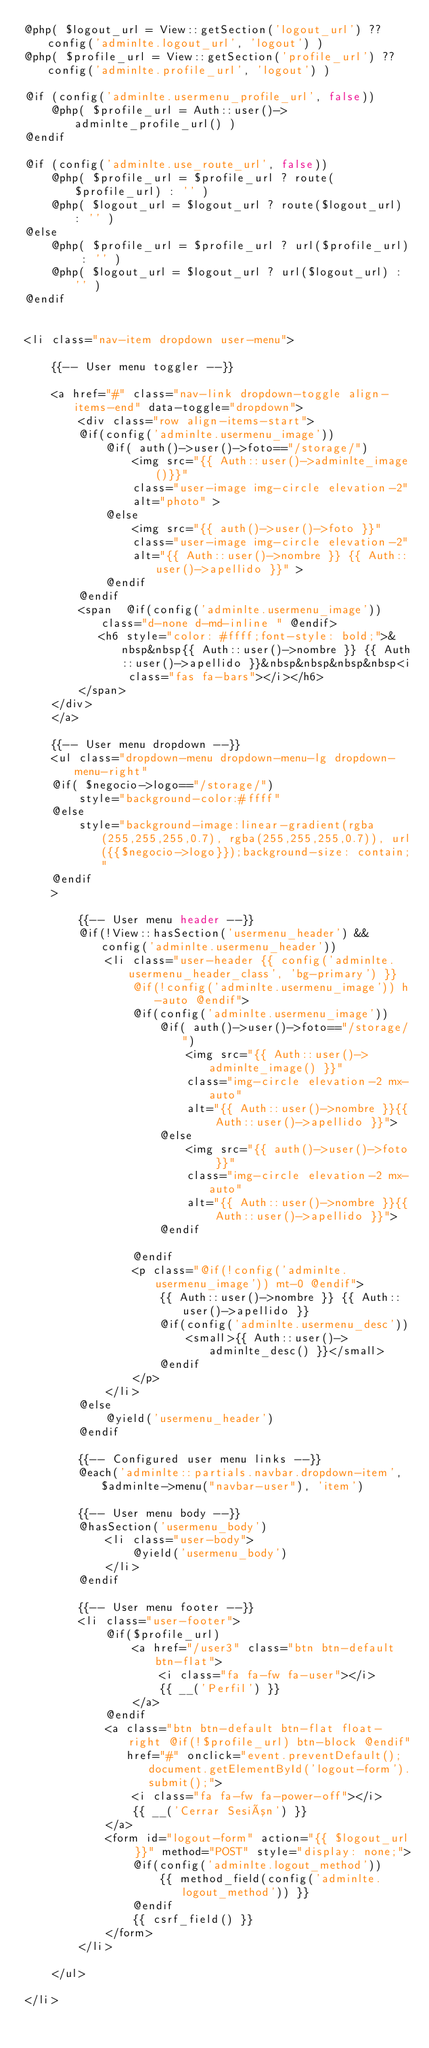<code> <loc_0><loc_0><loc_500><loc_500><_PHP_>@php( $logout_url = View::getSection('logout_url') ?? config('adminlte.logout_url', 'logout') )
@php( $profile_url = View::getSection('profile_url') ?? config('adminlte.profile_url', 'logout') )

@if (config('adminlte.usermenu_profile_url', false))
    @php( $profile_url = Auth::user()->adminlte_profile_url() )
@endif

@if (config('adminlte.use_route_url', false))
    @php( $profile_url = $profile_url ? route($profile_url) : '' )
    @php( $logout_url = $logout_url ? route($logout_url) : '' )
@else
    @php( $profile_url = $profile_url ? url($profile_url) : '' )
    @php( $logout_url = $logout_url ? url($logout_url) : '' )
@endif


<li class="nav-item dropdown user-menu">

    {{-- User menu toggler --}} 
    
    <a href="#" class="nav-link dropdown-toggle align-items-end" data-toggle="dropdown">
        <div class="row align-items-start">
        @if(config('adminlte.usermenu_image'))
            @if( auth()->user()->foto=="/storage/") 
                <img src="{{ Auth::user()->adminlte_image()}}"
                class="user-image img-circle elevation-2"
                alt="photo" >
            @else 
                <img src="{{ auth()->user()->foto }}"
                class="user-image img-circle elevation-2"
                alt="{{ Auth::user()->nombre }} {{ Auth::user()->apellido }}" >
            @endif
        @endif
        <span  @if(config('adminlte.usermenu_image')) class="d-none d-md-inline " @endif>
           <h6 style="color: #ffff;font-style: bold;">&nbsp&nbsp{{ Auth::user()->nombre }} {{ Auth::user()->apellido }}&nbsp&nbsp&nbsp&nbsp<i class="fas fa-bars"></i></h6>
        </span>
    </div>
    </a>
    
    {{-- User menu dropdown --}}
    <ul class="dropdown-menu dropdown-menu-lg dropdown-menu-right"
    @if( $negocio->logo=="/storage/")  
        style="background-color:#ffff" 
    @else
        style="background-image:linear-gradient(rgba(255,255,255,0.7), rgba(255,255,255,0.7)), url({{$negocio->logo}});background-size: contain;"
    @endif
    >

        {{-- User menu header --}}
        @if(!View::hasSection('usermenu_header') && config('adminlte.usermenu_header'))
            <li class="user-header {{ config('adminlte.usermenu_header_class', 'bg-primary') }}
                @if(!config('adminlte.usermenu_image')) h-auto @endif">
                @if(config('adminlte.usermenu_image'))
                    @if( auth()->user()->foto=="/storage/") 
                        <img src="{{ Auth::user()->adminlte_image() }}"
                        class="img-circle elevation-2 mx-auto"
                        alt="{{ Auth::user()->nombre }}{{ Auth::user()->apellido }}">
                    @else 
                        <img src="{{ auth()->user()->foto }}"
                        class="img-circle elevation-2 mx-auto"
                        alt="{{ Auth::user()->nombre }}{{ Auth::user()->apellido }}">
                    @endif
                    
                @endif
                <p class="@if(!config('adminlte.usermenu_image')) mt-0 @endif">
                    {{ Auth::user()->nombre }} {{ Auth::user()->apellido }}
                    @if(config('adminlte.usermenu_desc'))
                        <small>{{ Auth::user()->adminlte_desc() }}</small>
                    @endif
                </p>
            </li>
        @else
            @yield('usermenu_header')
        @endif

        {{-- Configured user menu links --}}
        @each('adminlte::partials.navbar.dropdown-item', $adminlte->menu("navbar-user"), 'item')

        {{-- User menu body --}}
        @hasSection('usermenu_body')
            <li class="user-body">
                @yield('usermenu_body')
            </li>
        @endif

        {{-- User menu footer --}}
        <li class="user-footer">
            @if($profile_url)
                <a href="/user3" class="btn btn-default btn-flat">
                    <i class="fa fa-fw fa-user"></i>
                    {{ __('Perfil') }}
                </a>
            @endif
            <a class="btn btn-default btn-flat float-right @if(!$profile_url) btn-block @endif"
               href="#" onclick="event.preventDefault(); document.getElementById('logout-form').submit();">
                <i class="fa fa-fw fa-power-off"></i>
                {{ __('Cerrar Sesión') }}
            </a>
            <form id="logout-form" action="{{ $logout_url }}" method="POST" style="display: none;">
                @if(config('adminlte.logout_method'))
                    {{ method_field(config('adminlte.logout_method')) }}
                @endif
                {{ csrf_field() }}
            </form>
        </li>

    </ul>

</li>
</code> 